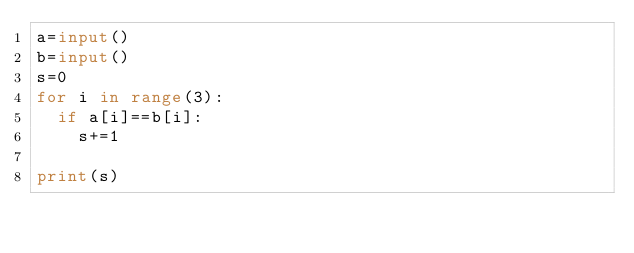<code> <loc_0><loc_0><loc_500><loc_500><_Python_>a=input()
b=input()
s=0
for i in range(3):
  if a[i]==b[i]:
    s+=1
    
print(s)</code> 